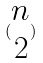<formula> <loc_0><loc_0><loc_500><loc_500>( \begin{matrix} n \\ 2 \end{matrix} )</formula> 